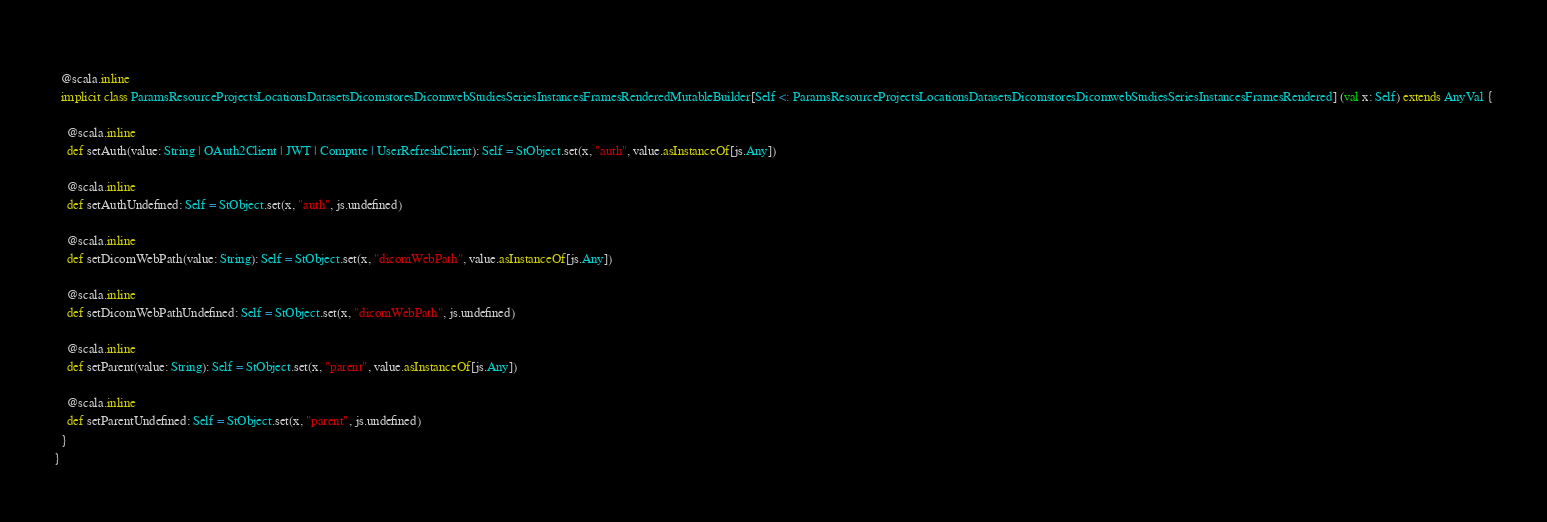Convert code to text. <code><loc_0><loc_0><loc_500><loc_500><_Scala_>  
  @scala.inline
  implicit class ParamsResourceProjectsLocationsDatasetsDicomstoresDicomwebStudiesSeriesInstancesFramesRenderedMutableBuilder[Self <: ParamsResourceProjectsLocationsDatasetsDicomstoresDicomwebStudiesSeriesInstancesFramesRendered] (val x: Self) extends AnyVal {
    
    @scala.inline
    def setAuth(value: String | OAuth2Client | JWT | Compute | UserRefreshClient): Self = StObject.set(x, "auth", value.asInstanceOf[js.Any])
    
    @scala.inline
    def setAuthUndefined: Self = StObject.set(x, "auth", js.undefined)
    
    @scala.inline
    def setDicomWebPath(value: String): Self = StObject.set(x, "dicomWebPath", value.asInstanceOf[js.Any])
    
    @scala.inline
    def setDicomWebPathUndefined: Self = StObject.set(x, "dicomWebPath", js.undefined)
    
    @scala.inline
    def setParent(value: String): Self = StObject.set(x, "parent", value.asInstanceOf[js.Any])
    
    @scala.inline
    def setParentUndefined: Self = StObject.set(x, "parent", js.undefined)
  }
}
</code> 